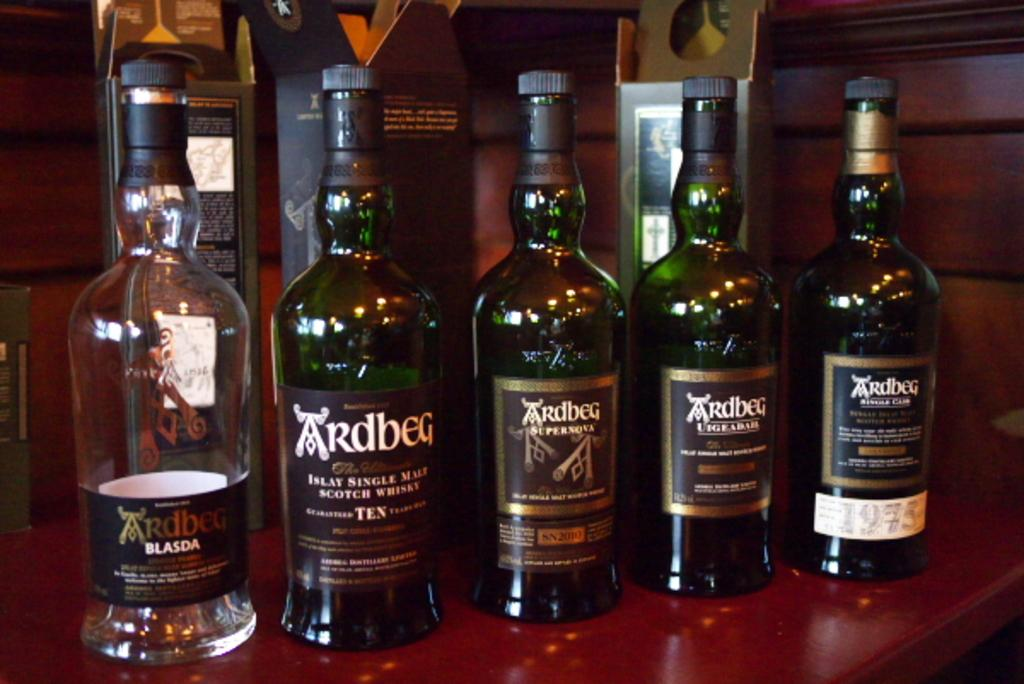<image>
Share a concise interpretation of the image provided. Bottles of Ardbeg alcohol including single malt scotch whiskey. 